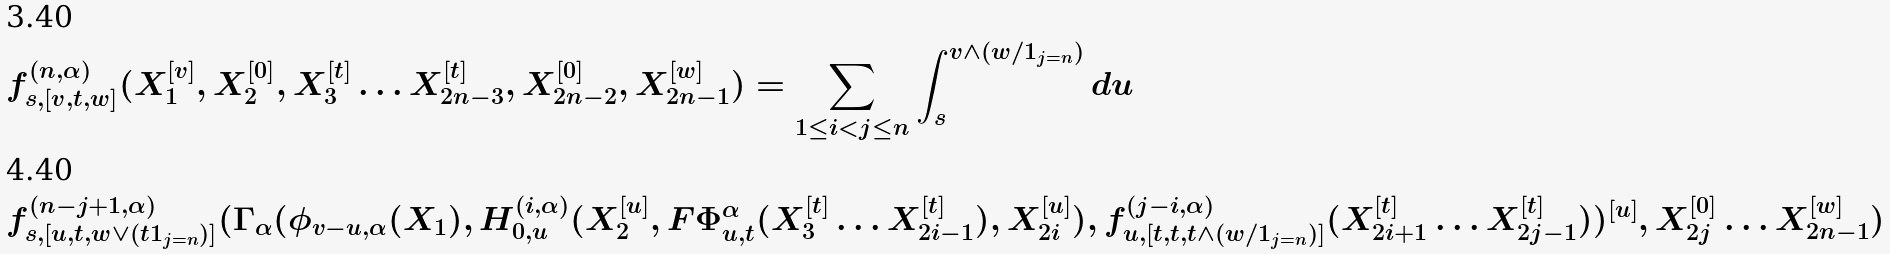Convert formula to latex. <formula><loc_0><loc_0><loc_500><loc_500>& f _ { s , [ v , t , w ] } ^ { ( n , \alpha ) } ( X _ { 1 } ^ { [ v ] } , X _ { 2 } ^ { [ 0 ] } , X _ { 3 } ^ { [ t ] } \dots X _ { 2 n - 3 } ^ { [ t ] } , X _ { 2 n - 2 } ^ { [ 0 ] } , X _ { 2 n - 1 } ^ { [ w ] } ) = \sum _ { 1 \leq i < j \leq n } \int _ { s } ^ { v \wedge ( w / 1 _ { j = n } ) } d u \ \\ & f _ { s , [ u , t , w \vee ( t 1 _ { j = n } ) ] } ^ { ( n - j + 1 , \alpha ) } ( \Gamma _ { \alpha } ( \phi _ { v - u , \alpha } ( X _ { 1 } ) , H _ { 0 , u } ^ { ( i , \alpha ) } ( X _ { 2 } ^ { [ u ] } , F \Phi _ { u , t } ^ { \alpha } ( X _ { 3 } ^ { [ t ] } \dots X _ { 2 i - 1 } ^ { [ t ] } ) , X _ { 2 i } ^ { [ u ] } ) , f _ { u , [ t , t , t \wedge ( w / 1 _ { j = n } ) ] } ^ { ( j - i , \alpha ) } ( X _ { 2 i + 1 } ^ { [ t ] } \dots X _ { 2 j - 1 } ^ { [ t ] } ) ) ^ { [ u ] } , X _ { 2 j } ^ { [ 0 ] } \dots X _ { 2 n - 1 } ^ { [ w ] } )</formula> 